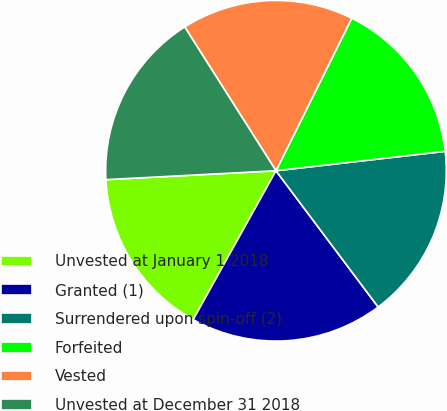Convert chart. <chart><loc_0><loc_0><loc_500><loc_500><pie_chart><fcel>Unvested at January 1 2018<fcel>Granted (1)<fcel>Surrendered upon spin-off (2)<fcel>Forfeited<fcel>Vested<fcel>Unvested at December 31 2018<nl><fcel>16.09%<fcel>18.32%<fcel>16.58%<fcel>15.84%<fcel>16.34%<fcel>16.83%<nl></chart> 